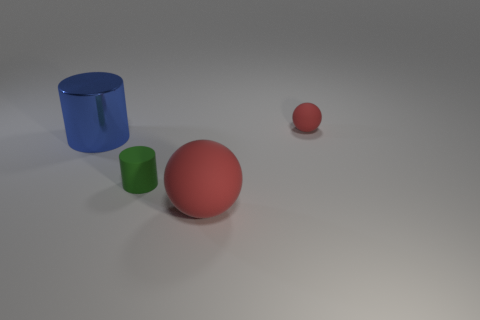How many other objects are the same color as the large ball?
Your answer should be compact. 1. Are there fewer spheres that are in front of the big blue object than red spheres that are right of the tiny green cylinder?
Offer a very short reply. Yes. What number of red blocks are there?
Give a very brief answer. 0. Is there anything else that is made of the same material as the big blue cylinder?
Make the answer very short. No. There is another thing that is the same shape as the large red object; what is its material?
Your answer should be compact. Rubber. Is the number of small objects to the right of the green matte thing less than the number of red balls?
Provide a succinct answer. Yes. There is a small object that is in front of the metallic cylinder; is it the same shape as the big blue object?
Your answer should be very brief. Yes. Is there any other thing of the same color as the metallic thing?
Make the answer very short. No. The green thing that is made of the same material as the tiny ball is what size?
Offer a very short reply. Small. What is the material of the big object that is in front of the tiny matte thing that is on the left side of the rubber sphere that is behind the blue thing?
Keep it short and to the point. Rubber. 